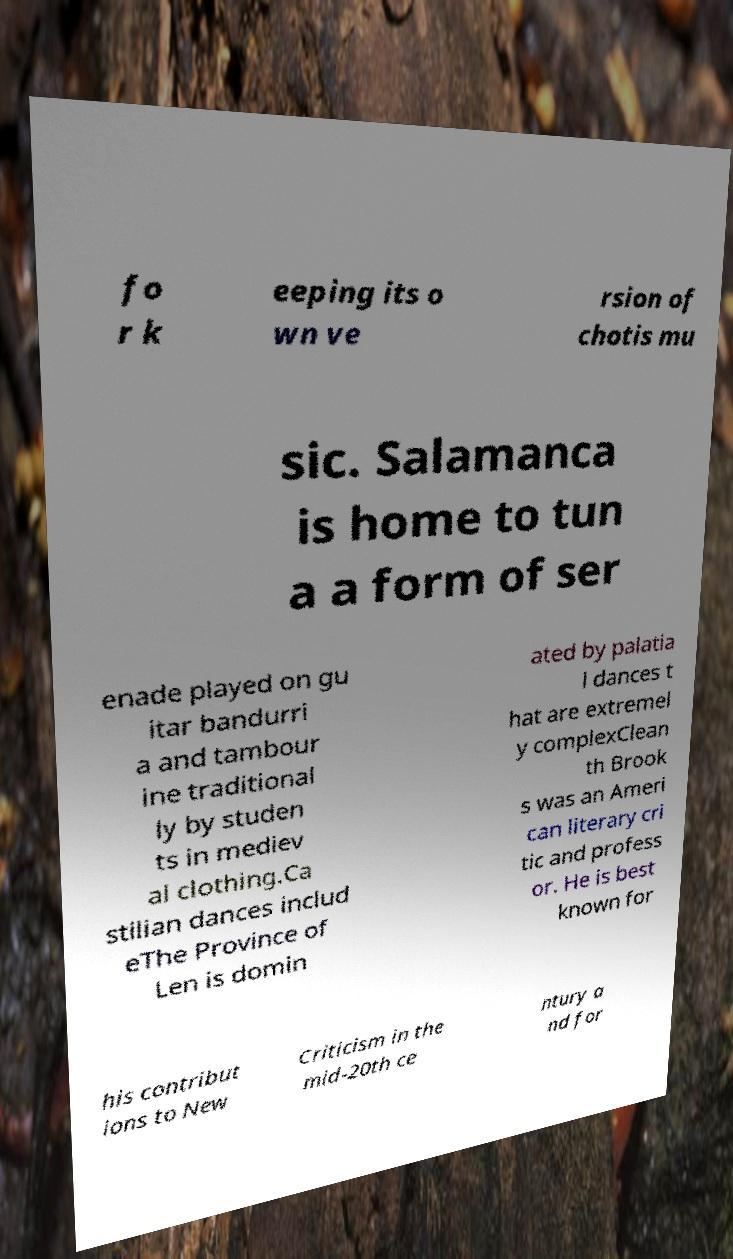What messages or text are displayed in this image? I need them in a readable, typed format. fo r k eeping its o wn ve rsion of chotis mu sic. Salamanca is home to tun a a form of ser enade played on gu itar bandurri a and tambour ine traditional ly by studen ts in mediev al clothing.Ca stilian dances includ eThe Province of Len is domin ated by palatia l dances t hat are extremel y complexClean th Brook s was an Ameri can literary cri tic and profess or. He is best known for his contribut ions to New Criticism in the mid-20th ce ntury a nd for 